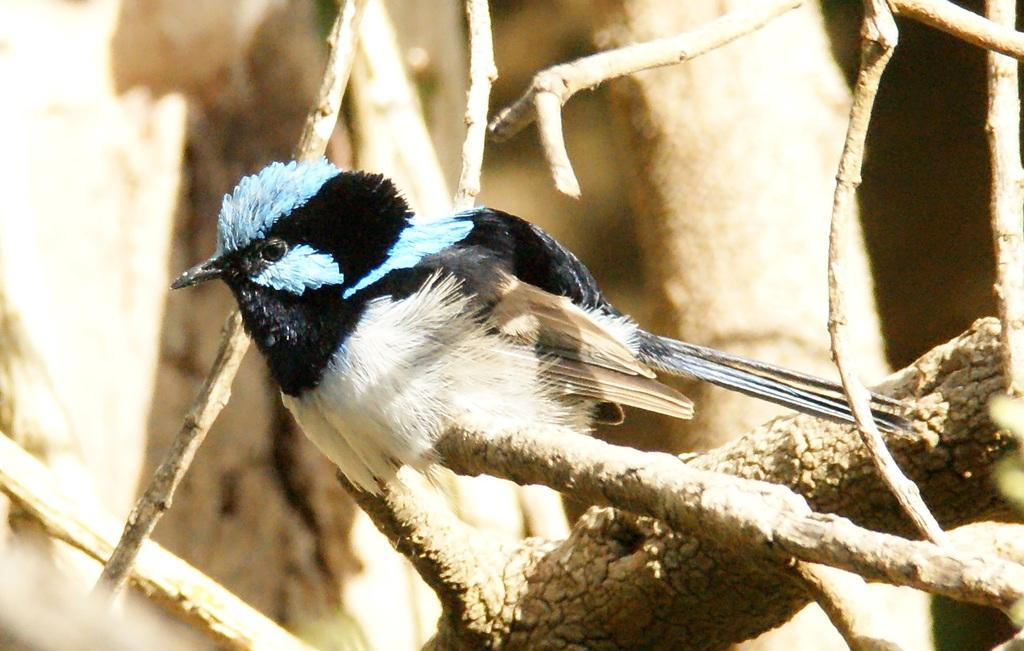What type of animal can be seen in the image? There is a bird in the image. Where is the bird located in the image? The bird is sitting on a stem. What type of crate is visible in the image? There is no crate present in the image. What kind of argument can be heard between the bird and the stem in the image? There is no argument between the bird and the stem in the image, as they are inanimate objects and cannot engage in such interactions. 